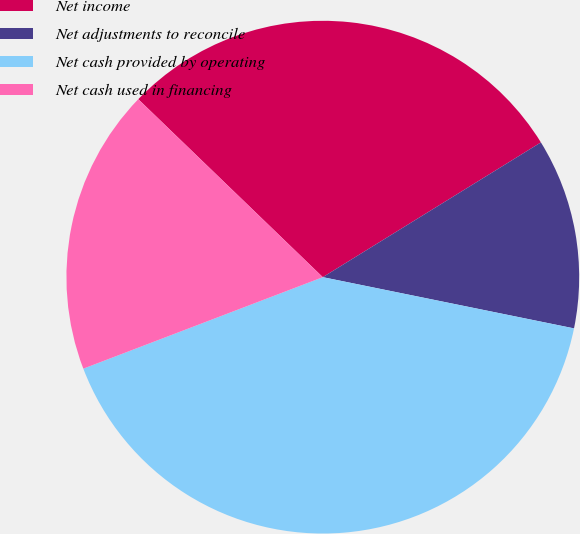Convert chart. <chart><loc_0><loc_0><loc_500><loc_500><pie_chart><fcel>Net income<fcel>Net adjustments to reconcile<fcel>Net cash provided by operating<fcel>Net cash used in financing<nl><fcel>28.98%<fcel>12.01%<fcel>40.99%<fcel>18.02%<nl></chart> 